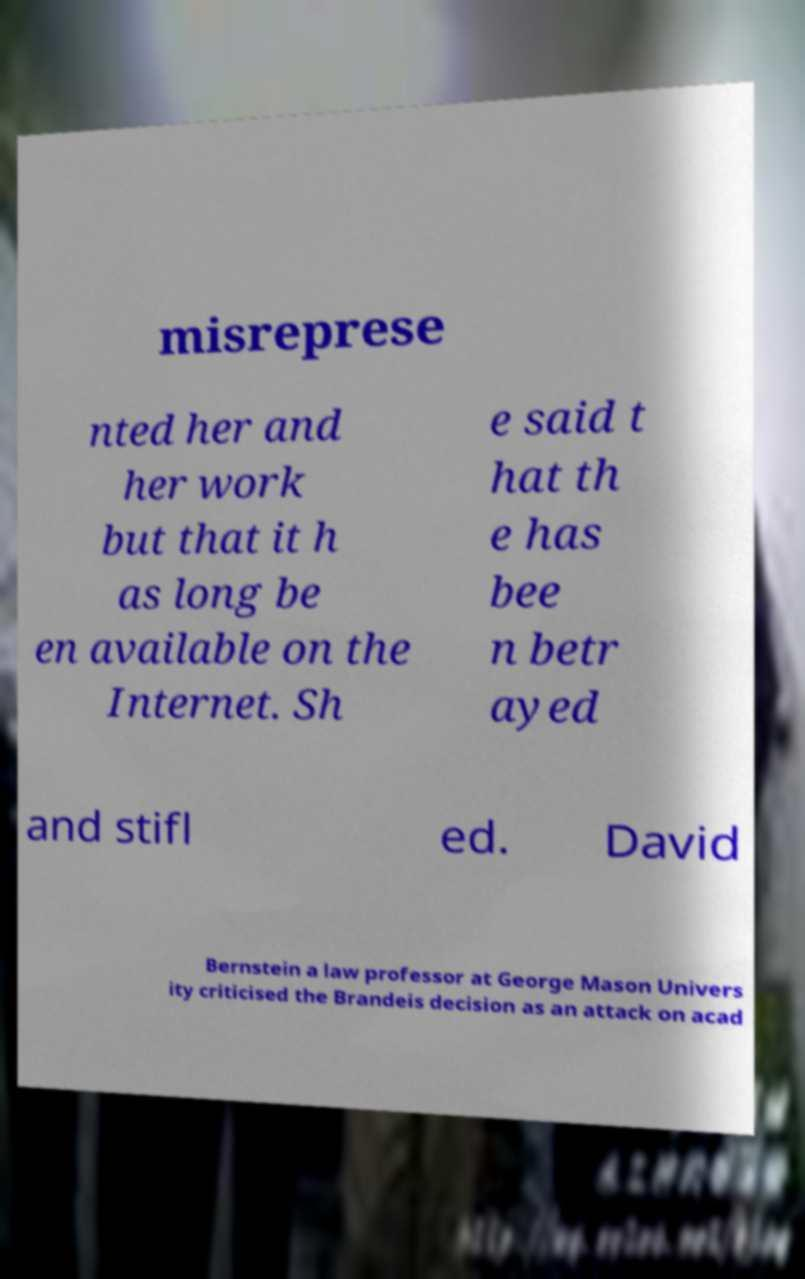Please identify and transcribe the text found in this image. misreprese nted her and her work but that it h as long be en available on the Internet. Sh e said t hat th e has bee n betr ayed and stifl ed. David Bernstein a law professor at George Mason Univers ity criticised the Brandeis decision as an attack on acad 